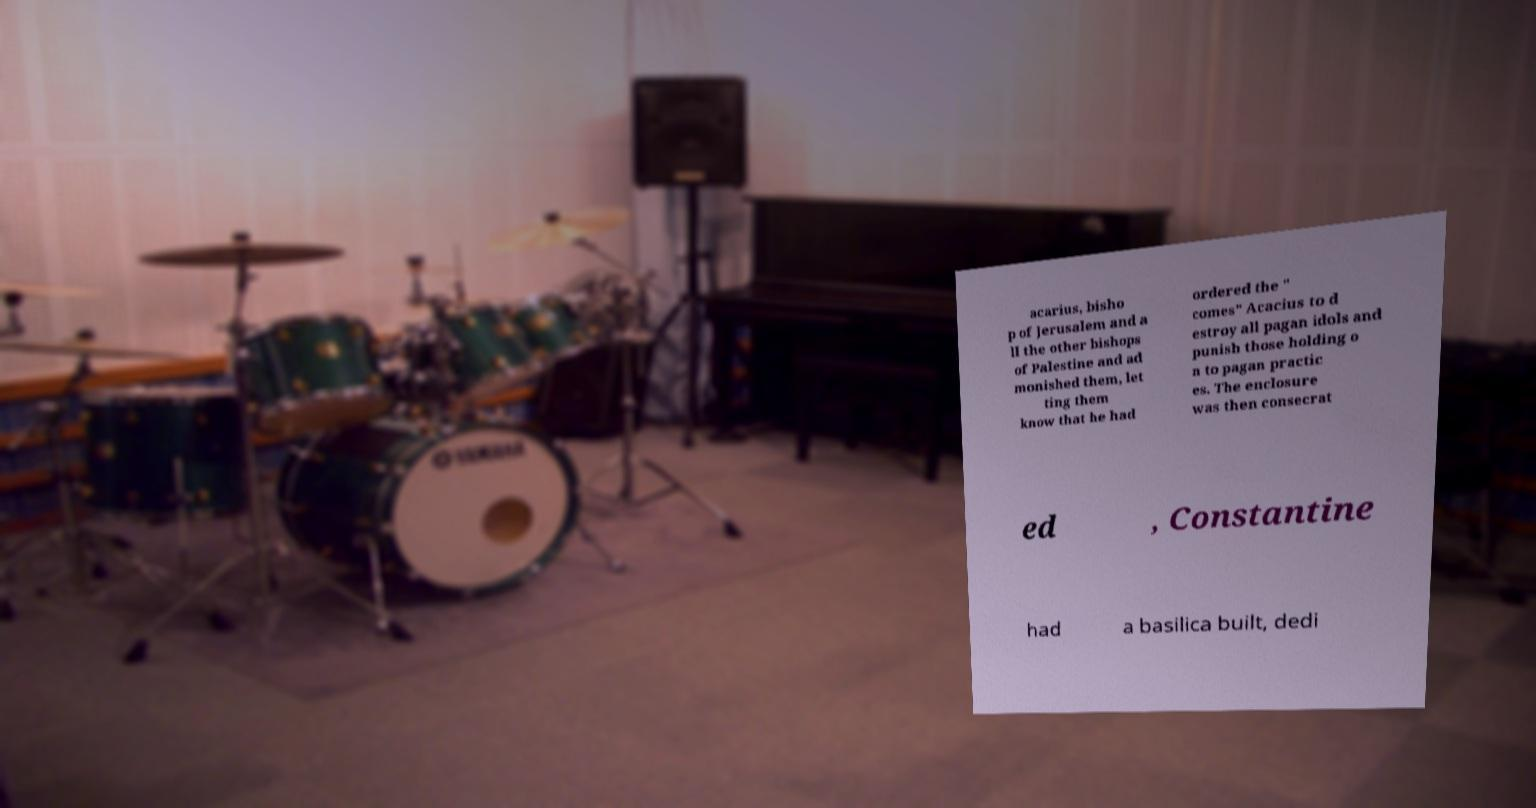Please identify and transcribe the text found in this image. acarius, bisho p of Jerusalem and a ll the other bishops of Palestine and ad monished them, let ting them know that he had ordered the " comes" Acacius to d estroy all pagan idols and punish those holding o n to pagan practic es. The enclosure was then consecrat ed , Constantine had a basilica built, dedi 